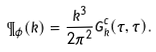<formula> <loc_0><loc_0><loc_500><loc_500>\P _ { \phi } ( k ) = \frac { k ^ { 3 } } { 2 \pi ^ { 2 } } G _ { \vec { k } } ^ { c } ( \tau , \tau ) .</formula> 